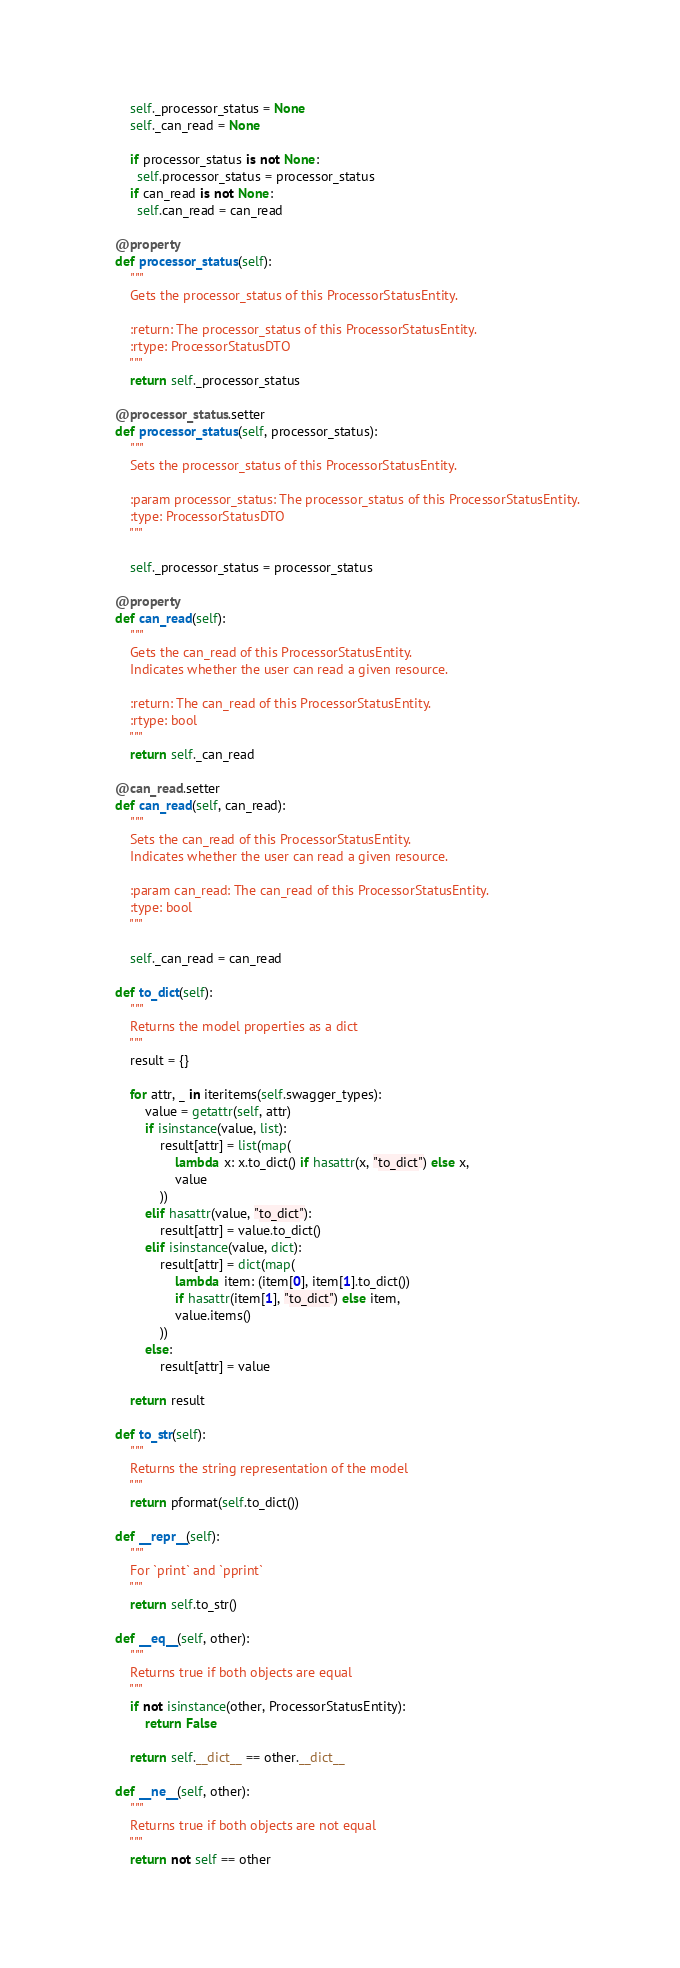Convert code to text. <code><loc_0><loc_0><loc_500><loc_500><_Python_>
        self._processor_status = None
        self._can_read = None

        if processor_status is not None:
          self.processor_status = processor_status
        if can_read is not None:
          self.can_read = can_read

    @property
    def processor_status(self):
        """
        Gets the processor_status of this ProcessorStatusEntity.

        :return: The processor_status of this ProcessorStatusEntity.
        :rtype: ProcessorStatusDTO
        """
        return self._processor_status

    @processor_status.setter
    def processor_status(self, processor_status):
        """
        Sets the processor_status of this ProcessorStatusEntity.

        :param processor_status: The processor_status of this ProcessorStatusEntity.
        :type: ProcessorStatusDTO
        """

        self._processor_status = processor_status

    @property
    def can_read(self):
        """
        Gets the can_read of this ProcessorStatusEntity.
        Indicates whether the user can read a given resource.

        :return: The can_read of this ProcessorStatusEntity.
        :rtype: bool
        """
        return self._can_read

    @can_read.setter
    def can_read(self, can_read):
        """
        Sets the can_read of this ProcessorStatusEntity.
        Indicates whether the user can read a given resource.

        :param can_read: The can_read of this ProcessorStatusEntity.
        :type: bool
        """

        self._can_read = can_read

    def to_dict(self):
        """
        Returns the model properties as a dict
        """
        result = {}

        for attr, _ in iteritems(self.swagger_types):
            value = getattr(self, attr)
            if isinstance(value, list):
                result[attr] = list(map(
                    lambda x: x.to_dict() if hasattr(x, "to_dict") else x,
                    value
                ))
            elif hasattr(value, "to_dict"):
                result[attr] = value.to_dict()
            elif isinstance(value, dict):
                result[attr] = dict(map(
                    lambda item: (item[0], item[1].to_dict())
                    if hasattr(item[1], "to_dict") else item,
                    value.items()
                ))
            else:
                result[attr] = value

        return result

    def to_str(self):
        """
        Returns the string representation of the model
        """
        return pformat(self.to_dict())

    def __repr__(self):
        """
        For `print` and `pprint`
        """
        return self.to_str()

    def __eq__(self, other):
        """
        Returns true if both objects are equal
        """
        if not isinstance(other, ProcessorStatusEntity):
            return False

        return self.__dict__ == other.__dict__

    def __ne__(self, other):
        """
        Returns true if both objects are not equal
        """
        return not self == other
</code> 